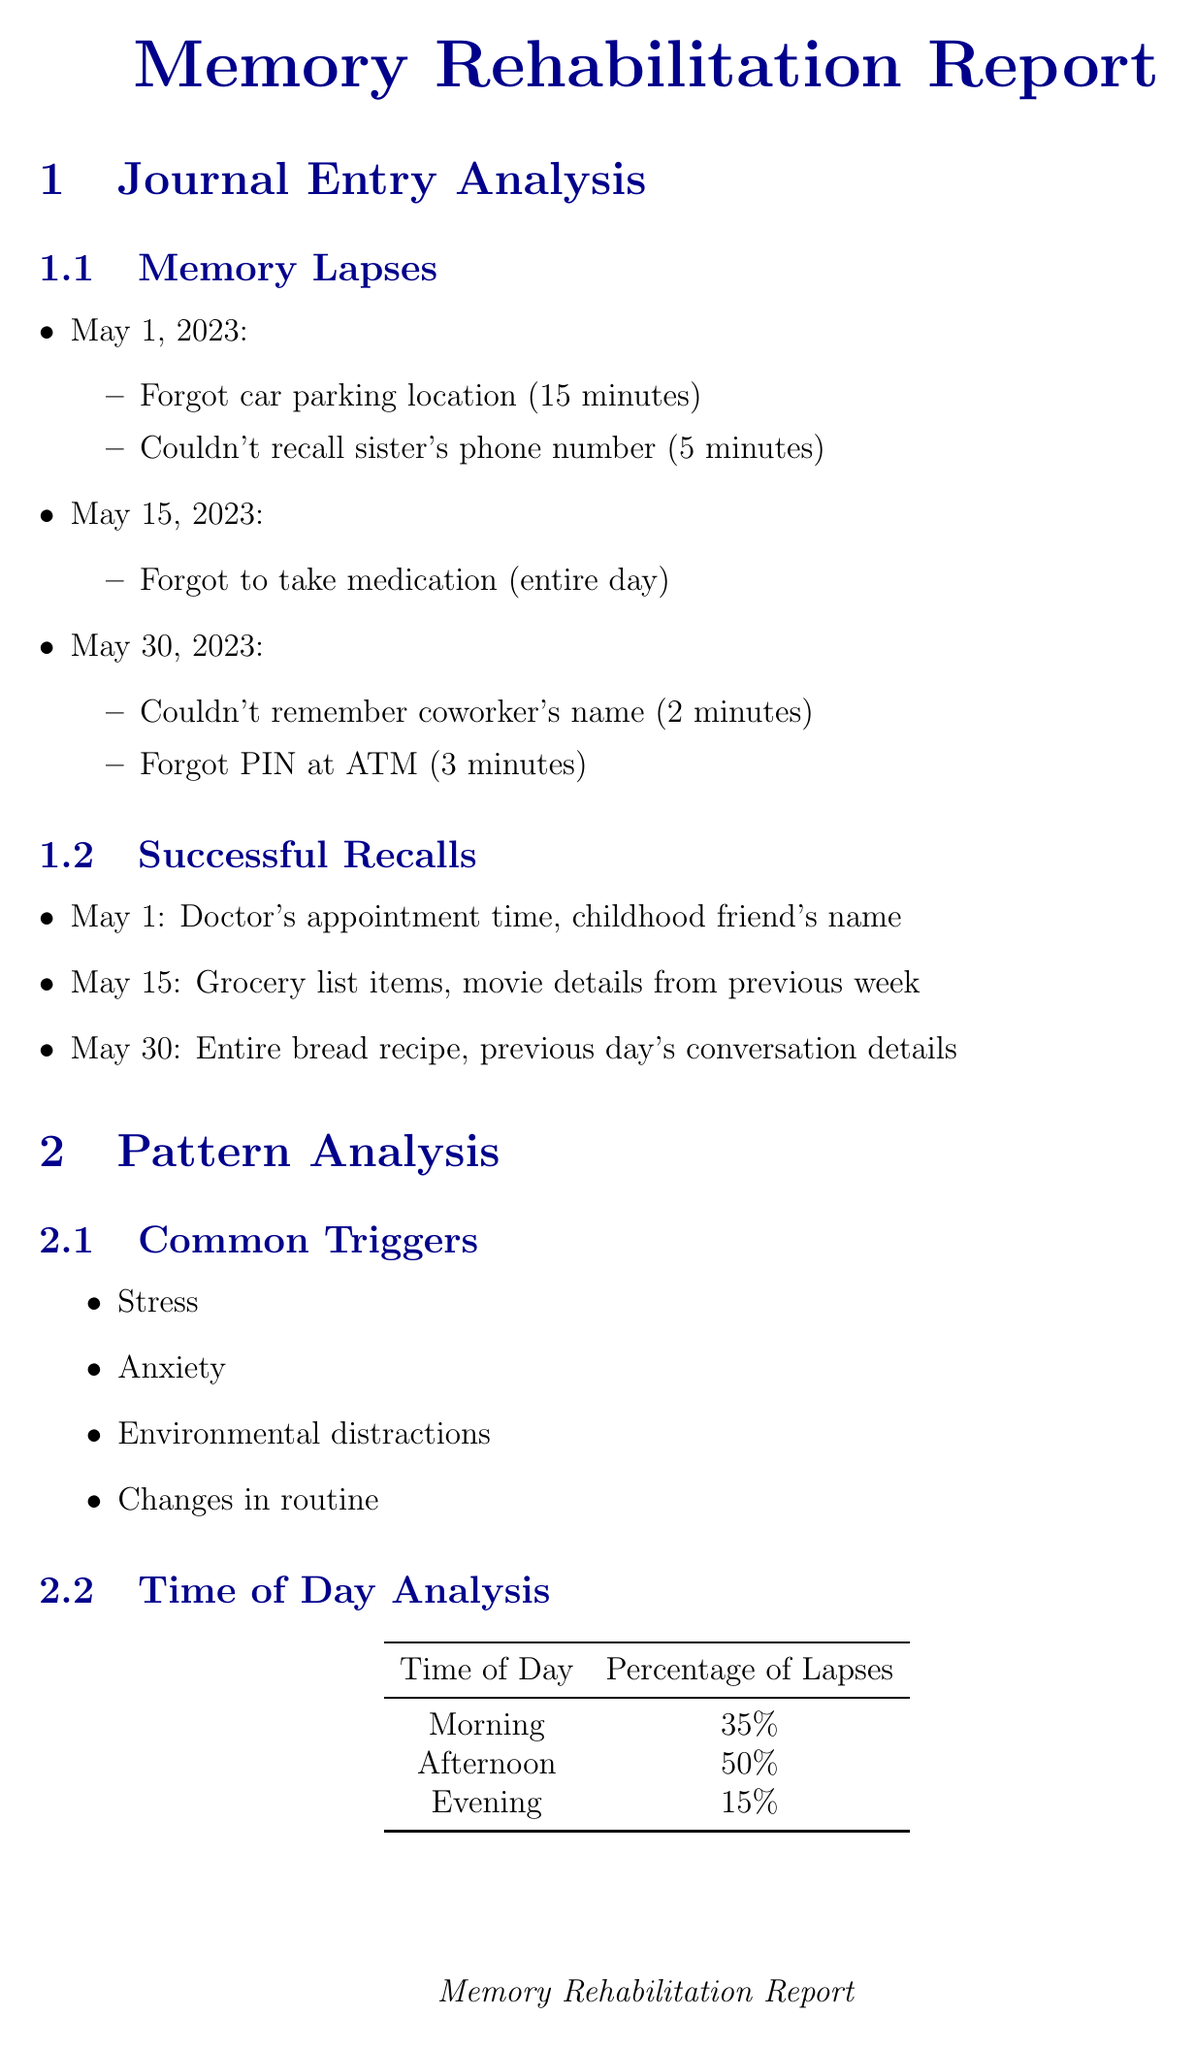What date had the longest memory lapse? The longest memory lapse occurred on May 15, 2023, which lasted an entire day.
Answer: May 15, 2023 What is the effectiveness of Spaced Retrieval? The effectiveness of Spaced Retrieval is categorized as "High for building long-term memory."
Answer: High How many memory lapses were recorded in the afternoon? The document indicates that there were 50% of the total memory lapses in the afternoon based on the time of day analysis.
Answer: 50 Which rehabilitation technique focuses on reducing stress? Mindfulness Meditation is aimed at practicing focused attention to reduce stress.
Answer: Mindfulness Meditation What is one area for improvement identified in the analysis? One area identified for improvement is "Name recall."
Answer: Name recall Who recommended using visualization techniques for memory enhancement? Dr. Daniel Schacter from Harvard University recommended utilizing visualization techniques.
Answer: Dr. Daniel Schacter What was a common trigger for memory lapses? The common triggers for memory lapses included "Stress."
Answer: Stress What is the website for the Amnesia Support Network? The website for the Amnesia Support Network is provided in the document.
Answer: www.amnesiasupport.org 